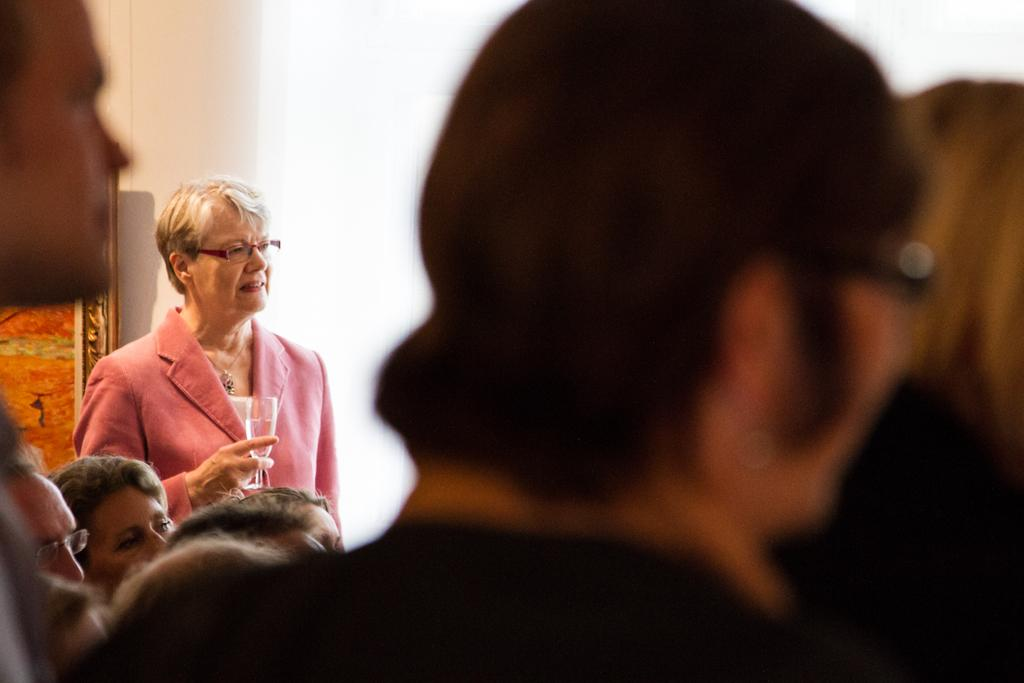What can be seen in the image involving multiple individuals? There is a group of people in the image. Can you describe the woman in the image? There is a woman standing in the image, and she is holding a glass. What is present on the wall in the image? There is a frame on the wall in the image. How many pizzas are being served by the woman in the image? There is no mention of pizzas in the image; the woman is holding a glass. What type of shoes is the woman wearing in the image? The image does not show the woman's shoes, so it cannot be determined from the image. 